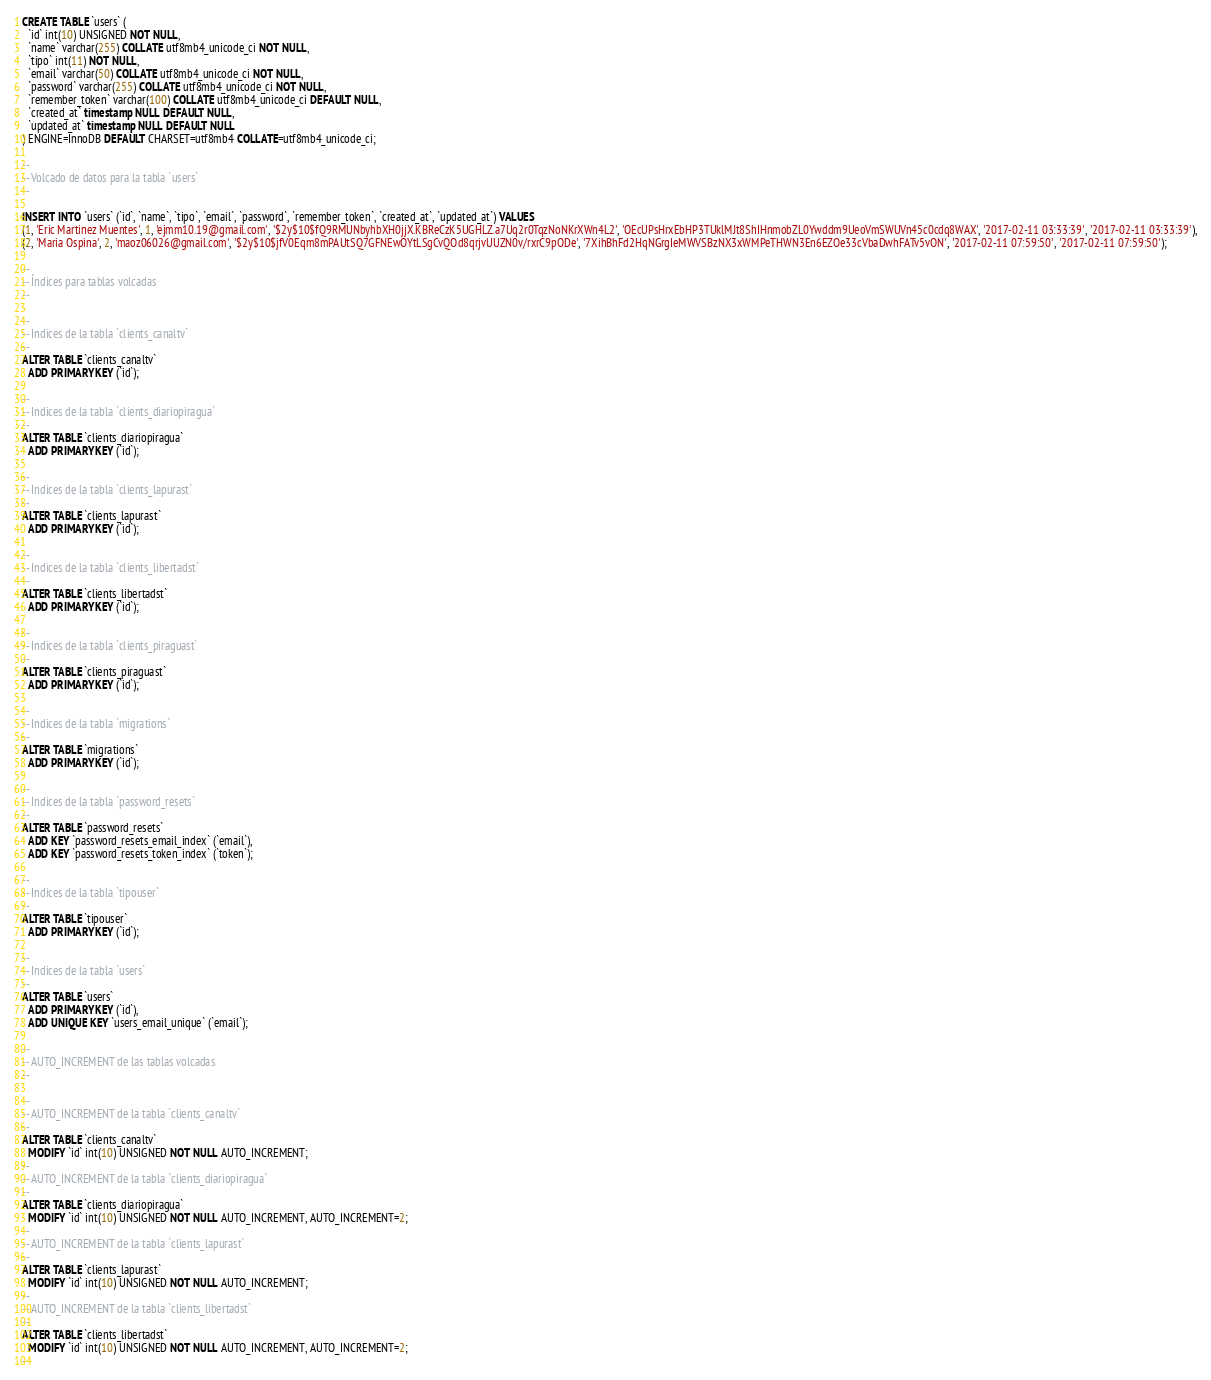<code> <loc_0><loc_0><loc_500><loc_500><_SQL_>CREATE TABLE `users` (
  `id` int(10) UNSIGNED NOT NULL,
  `name` varchar(255) COLLATE utf8mb4_unicode_ci NOT NULL,
  `tipo` int(11) NOT NULL,
  `email` varchar(50) COLLATE utf8mb4_unicode_ci NOT NULL,
  `password` varchar(255) COLLATE utf8mb4_unicode_ci NOT NULL,
  `remember_token` varchar(100) COLLATE utf8mb4_unicode_ci DEFAULT NULL,
  `created_at` timestamp NULL DEFAULT NULL,
  `updated_at` timestamp NULL DEFAULT NULL
) ENGINE=InnoDB DEFAULT CHARSET=utf8mb4 COLLATE=utf8mb4_unicode_ci;

--
-- Volcado de datos para la tabla `users`
--

INSERT INTO `users` (`id`, `name`, `tipo`, `email`, `password`, `remember_token`, `created_at`, `updated_at`) VALUES
(1, 'Eric Martinez Muentes', 1, 'ejmm10.19@gmail.com', '$2y$10$fQ9RMUNbyhbXH0jjX.KBReCzK5UGHLZ.a7Uq2r0TqzNoNKrXWn4L2', 'OEcUPsHrxEbHP3TUklMJt8ShIHnmobZL0Ywddm9UeoVmSWUVn45c0cdq8WAX', '2017-02-11 03:33:39', '2017-02-11 03:33:39'),
(2, 'Maria Ospina', 2, 'maoz06026@gmail.com', '$2y$10$jfV0Eqm8mPAUtSQ7GFNEwOYtLSgCvQOd8qrjvUUZN0v/rxrC9pODe', '7XihBhFd2HqNGrgIeMWVSBzNX3xWMPeTHWN3En6EZOe33cVbaDwhFATv5vON', '2017-02-11 07:59:50', '2017-02-11 07:59:50');

--
-- Índices para tablas volcadas
--

--
-- Indices de la tabla `clients_canaltv`
--
ALTER TABLE `clients_canaltv`
  ADD PRIMARY KEY (`id`);

--
-- Indices de la tabla `clients_diariopiragua`
--
ALTER TABLE `clients_diariopiragua`
  ADD PRIMARY KEY (`id`);

--
-- Indices de la tabla `clients_lapurast`
--
ALTER TABLE `clients_lapurast`
  ADD PRIMARY KEY (`id`);

--
-- Indices de la tabla `clients_libertadst`
--
ALTER TABLE `clients_libertadst`
  ADD PRIMARY KEY (`id`);

--
-- Indices de la tabla `clients_piraguast`
--
ALTER TABLE `clients_piraguast`
  ADD PRIMARY KEY (`id`);

--
-- Indices de la tabla `migrations`
--
ALTER TABLE `migrations`
  ADD PRIMARY KEY (`id`);

--
-- Indices de la tabla `password_resets`
--
ALTER TABLE `password_resets`
  ADD KEY `password_resets_email_index` (`email`),
  ADD KEY `password_resets_token_index` (`token`);

--
-- Indices de la tabla `tipouser`
--
ALTER TABLE `tipouser`
  ADD PRIMARY KEY (`id`);

--
-- Indices de la tabla `users`
--
ALTER TABLE `users`
  ADD PRIMARY KEY (`id`),
  ADD UNIQUE KEY `users_email_unique` (`email`);

--
-- AUTO_INCREMENT de las tablas volcadas
--

--
-- AUTO_INCREMENT de la tabla `clients_canaltv`
--
ALTER TABLE `clients_canaltv`
  MODIFY `id` int(10) UNSIGNED NOT NULL AUTO_INCREMENT;
--
-- AUTO_INCREMENT de la tabla `clients_diariopiragua`
--
ALTER TABLE `clients_diariopiragua`
  MODIFY `id` int(10) UNSIGNED NOT NULL AUTO_INCREMENT, AUTO_INCREMENT=2;
--
-- AUTO_INCREMENT de la tabla `clients_lapurast`
--
ALTER TABLE `clients_lapurast`
  MODIFY `id` int(10) UNSIGNED NOT NULL AUTO_INCREMENT;
--
-- AUTO_INCREMENT de la tabla `clients_libertadst`
--
ALTER TABLE `clients_libertadst`
  MODIFY `id` int(10) UNSIGNED NOT NULL AUTO_INCREMENT, AUTO_INCREMENT=2;
--</code> 